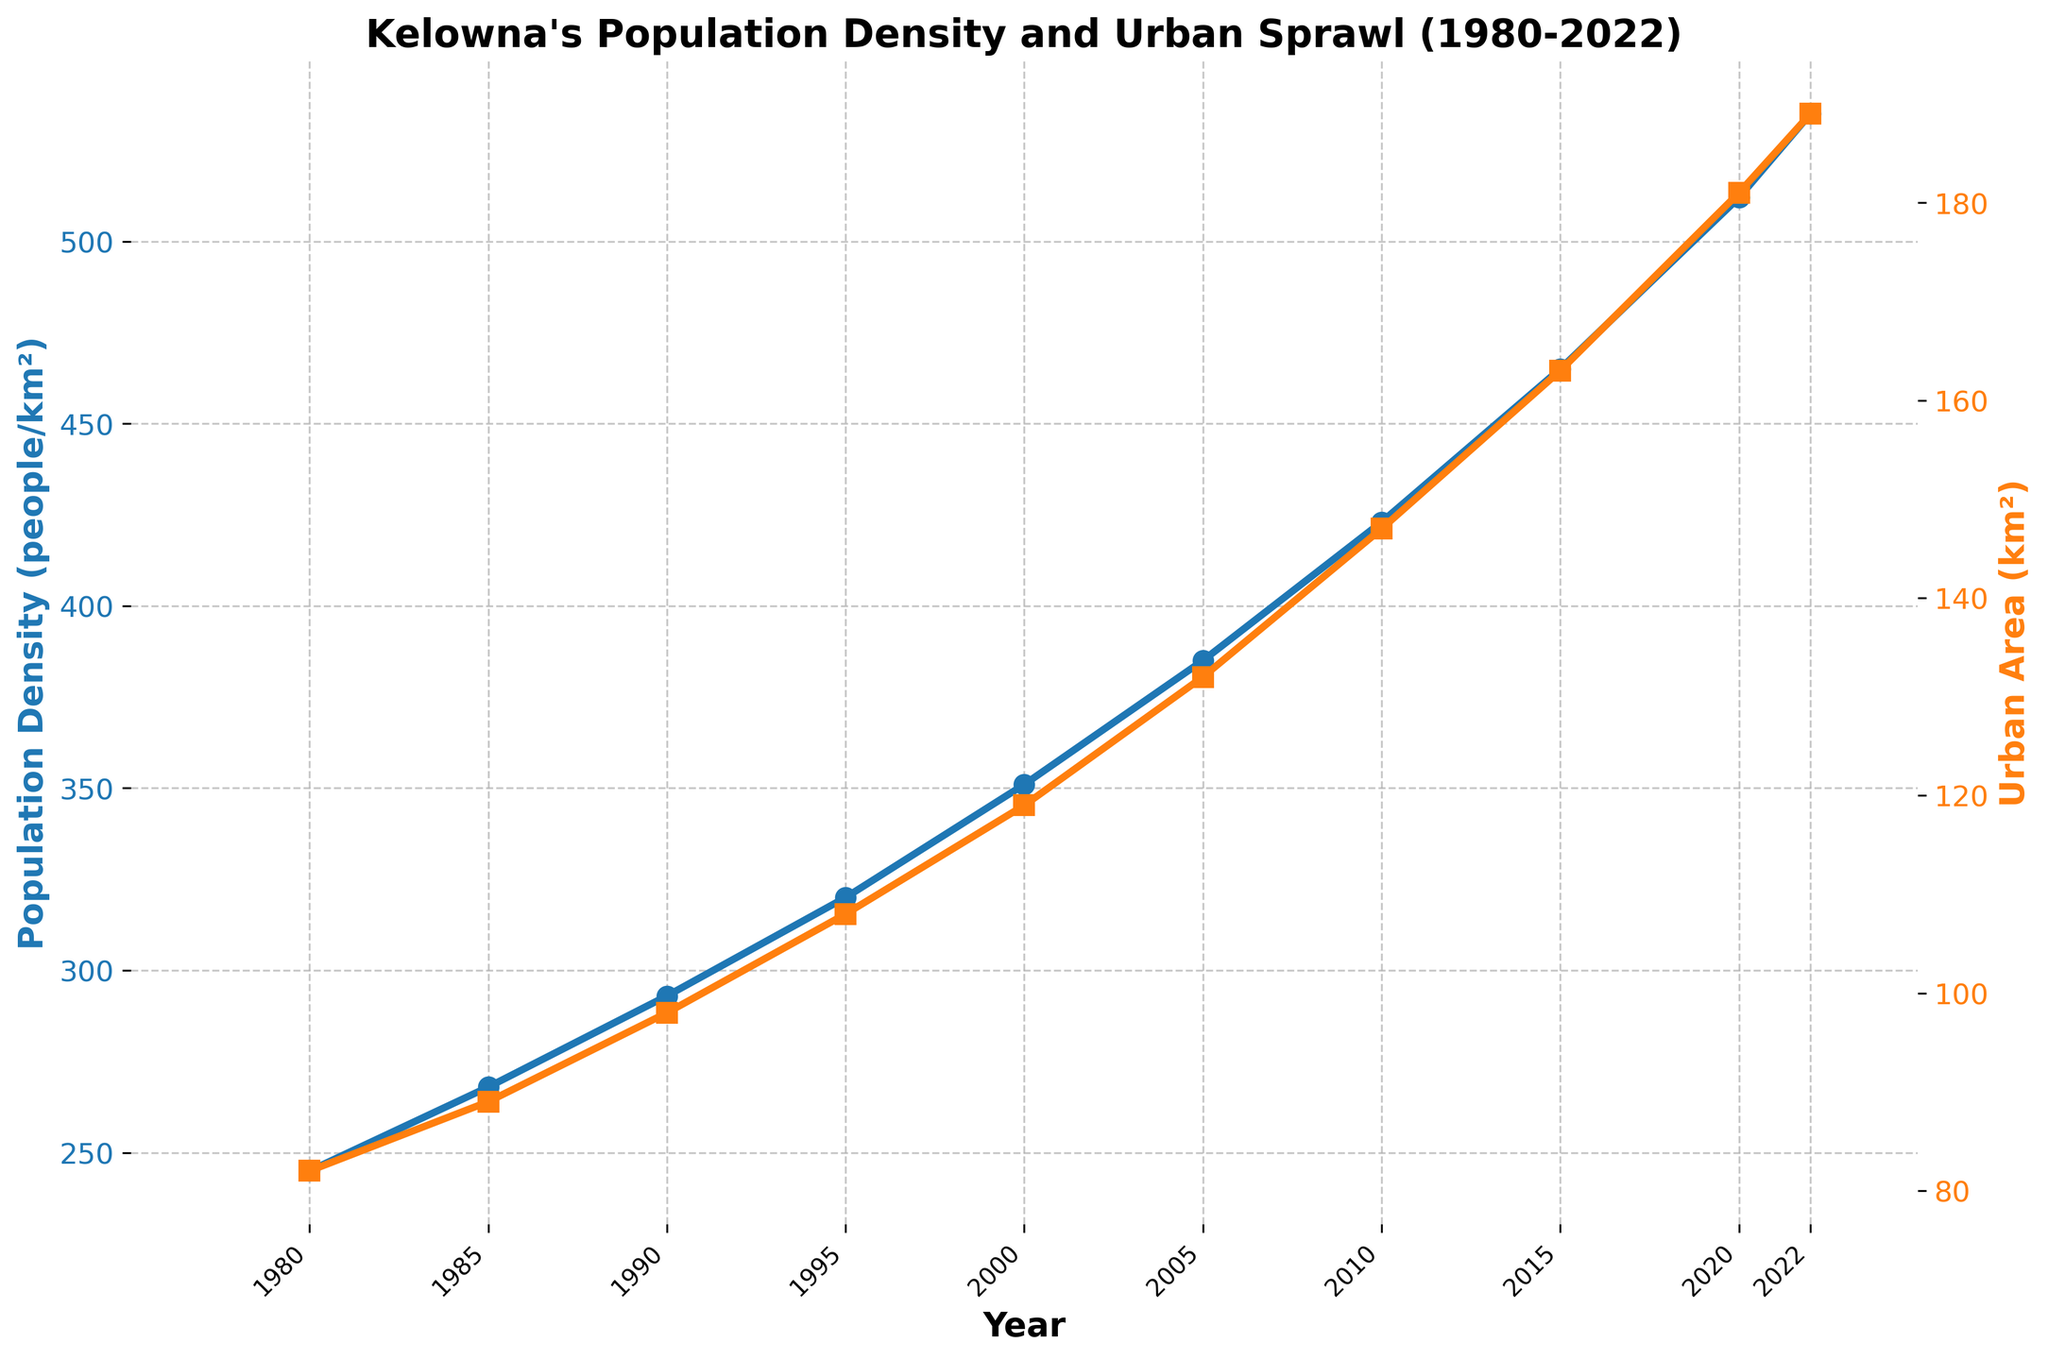Which year saw the maximum population density? By observing the line for population density, check the peak value and correlate it with the year on the x-axis.
Answer: 2022 How much did the urban area increase from 1980 to 2000? Check the urban area values in 1980 and 2000, then calculate the difference: 119 km² (2000) - 82 km² (1980) = 37 km².
Answer: 37 km² By how much did the population density increase from 1990 to 2010? Find the population density in 1990 and 2010, then calculate the difference: 423 people/km² (2010) - 293 people/km² (1990) = 130 people/km².
Answer: 130 people/km² What is the average population density for the years 1985, 1995, and 2005? Add the population density values for these years and divide by 3: (268 + 320 + 385) / 3 = 324.33 people/km².
Answer: 324.33 people/km² Which increased at a faster rate between 2000 and 2020, population density or urban area? Calculate the rate of increase for both metrics: Population Density: (512 - 351)/20 = 8 people/km² per year; Urban Area: (181 - 119)/20 = 3.1 km² per year.
Answer: Population Density Between which consecutive years did the population density see the highest increase? Calculate the difference in population density between each pair of consecutive years and find the maximum value: 512 (2020) - 465 (2015) = 47 people/km².
Answer: 2015-2020 Is the pattern of increase for urban area similar to that of population density? Compare the shape and trend of both lines. Both show a consistent increase over time, but specific segments need closer inspection to see patterns.
Answer: Similar trend What are the colors used for the population density and urban area lines, respectively? Observe the color of the lines representing population density and urban area. Population Density is blue, Urban Area is orange.
Answer: Blue, Orange By what percentage did the urban area grow from 1980 to 2022? Calculate the percentage increase: [(189 - 82) / 82] * 100 = 130.49%.
Answer: 130.49% Which year experienced a larger relative increase in urban area compared to population density, 2010 or 2015? Calculate the percentage increase for each metric from the previous year for both 2010 and 2015. Check which year has a larger relative urban area increase.
Answer: 2015 